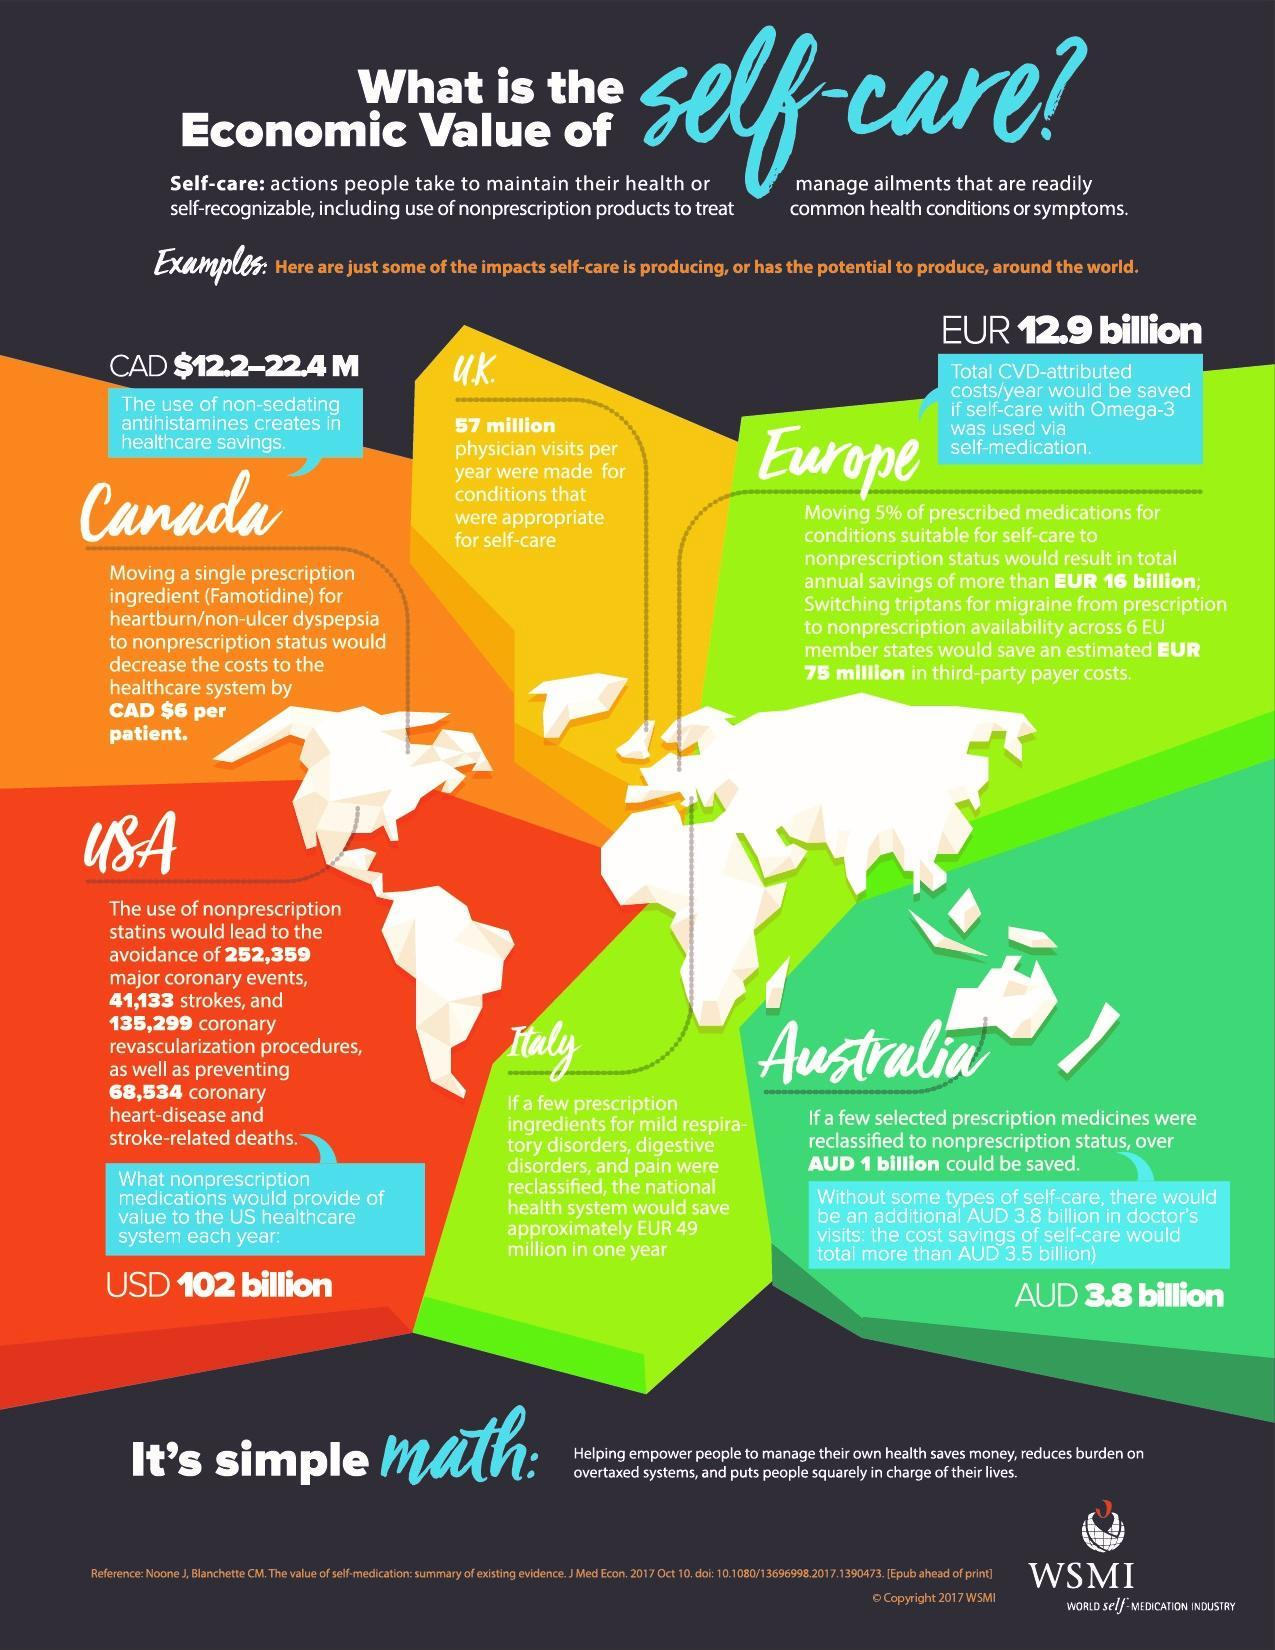How many geographic regions are mentioned in the map?
Answer the question with a short phrase. 6 What is the estimated amount of money saved by Australia if prescription medicines were classified, 1 billion, 3.5 billion or 3.8 billion? 3.8 billion What is total heart related disorders that can be avoided if non prescription statins were introduced ? 497,325 